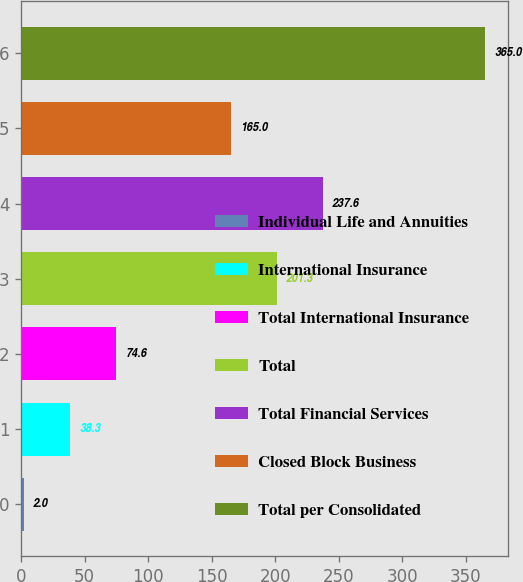Convert chart. <chart><loc_0><loc_0><loc_500><loc_500><bar_chart><fcel>Individual Life and Annuities<fcel>International Insurance<fcel>Total International Insurance<fcel>Total<fcel>Total Financial Services<fcel>Closed Block Business<fcel>Total per Consolidated<nl><fcel>2<fcel>38.3<fcel>74.6<fcel>201.3<fcel>237.6<fcel>165<fcel>365<nl></chart> 